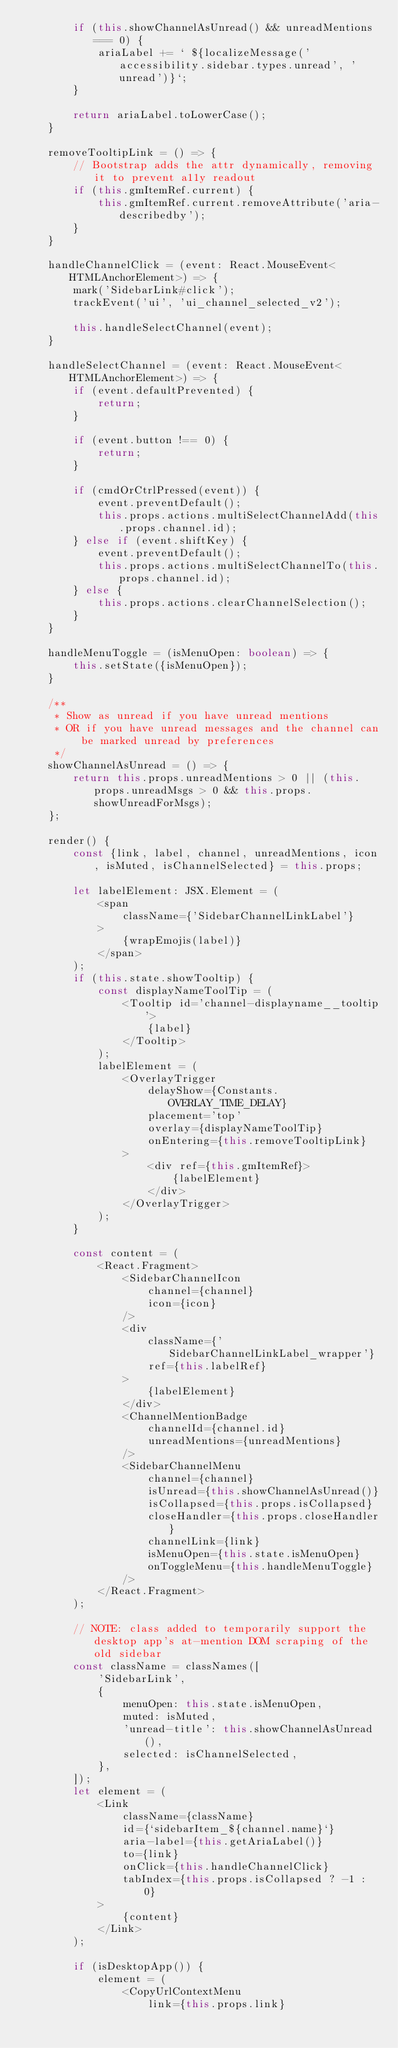Convert code to text. <code><loc_0><loc_0><loc_500><loc_500><_TypeScript_>        if (this.showChannelAsUnread() && unreadMentions === 0) {
            ariaLabel += ` ${localizeMessage('accessibility.sidebar.types.unread', 'unread')}`;
        }

        return ariaLabel.toLowerCase();
    }

    removeTooltipLink = () => {
        // Bootstrap adds the attr dynamically, removing it to prevent a11y readout
        if (this.gmItemRef.current) {
            this.gmItemRef.current.removeAttribute('aria-describedby');
        }
    }

    handleChannelClick = (event: React.MouseEvent<HTMLAnchorElement>) => {
        mark('SidebarLink#click');
        trackEvent('ui', 'ui_channel_selected_v2');

        this.handleSelectChannel(event);
    }

    handleSelectChannel = (event: React.MouseEvent<HTMLAnchorElement>) => {
        if (event.defaultPrevented) {
            return;
        }

        if (event.button !== 0) {
            return;
        }

        if (cmdOrCtrlPressed(event)) {
            event.preventDefault();
            this.props.actions.multiSelectChannelAdd(this.props.channel.id);
        } else if (event.shiftKey) {
            event.preventDefault();
            this.props.actions.multiSelectChannelTo(this.props.channel.id);
        } else {
            this.props.actions.clearChannelSelection();
        }
    }

    handleMenuToggle = (isMenuOpen: boolean) => {
        this.setState({isMenuOpen});
    }

    /**
     * Show as unread if you have unread mentions
     * OR if you have unread messages and the channel can be marked unread by preferences
     */
    showChannelAsUnread = () => {
        return this.props.unreadMentions > 0 || (this.props.unreadMsgs > 0 && this.props.showUnreadForMsgs);
    };

    render() {
        const {link, label, channel, unreadMentions, icon, isMuted, isChannelSelected} = this.props;

        let labelElement: JSX.Element = (
            <span
                className={'SidebarChannelLinkLabel'}
            >
                {wrapEmojis(label)}
            </span>
        );
        if (this.state.showTooltip) {
            const displayNameToolTip = (
                <Tooltip id='channel-displayname__tooltip'>
                    {label}
                </Tooltip>
            );
            labelElement = (
                <OverlayTrigger
                    delayShow={Constants.OVERLAY_TIME_DELAY}
                    placement='top'
                    overlay={displayNameToolTip}
                    onEntering={this.removeTooltipLink}
                >
                    <div ref={this.gmItemRef}>
                        {labelElement}
                    </div>
                </OverlayTrigger>
            );
        }

        const content = (
            <React.Fragment>
                <SidebarChannelIcon
                    channel={channel}
                    icon={icon}
                />
                <div
                    className={'SidebarChannelLinkLabel_wrapper'}
                    ref={this.labelRef}
                >
                    {labelElement}
                </div>
                <ChannelMentionBadge
                    channelId={channel.id}
                    unreadMentions={unreadMentions}
                />
                <SidebarChannelMenu
                    channel={channel}
                    isUnread={this.showChannelAsUnread()}
                    isCollapsed={this.props.isCollapsed}
                    closeHandler={this.props.closeHandler}
                    channelLink={link}
                    isMenuOpen={this.state.isMenuOpen}
                    onToggleMenu={this.handleMenuToggle}
                />
            </React.Fragment>
        );

        // NOTE: class added to temporarily support the desktop app's at-mention DOM scraping of the old sidebar
        const className = classNames([
            'SidebarLink',
            {
                menuOpen: this.state.isMenuOpen,
                muted: isMuted,
                'unread-title': this.showChannelAsUnread(),
                selected: isChannelSelected,
            },
        ]);
        let element = (
            <Link
                className={className}
                id={`sidebarItem_${channel.name}`}
                aria-label={this.getAriaLabel()}
                to={link}
                onClick={this.handleChannelClick}
                tabIndex={this.props.isCollapsed ? -1 : 0}
            >
                {content}
            </Link>
        );

        if (isDesktopApp()) {
            element = (
                <CopyUrlContextMenu
                    link={this.props.link}</code> 